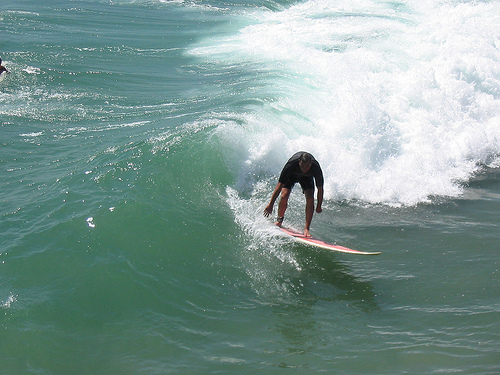Please provide the bounding box coordinate of the region this sentence describes: this is a wave. Coordinates for a wave are [0.5, 0.22, 0.72, 0.44], where the wave is forming a large swell next to the surfer. 